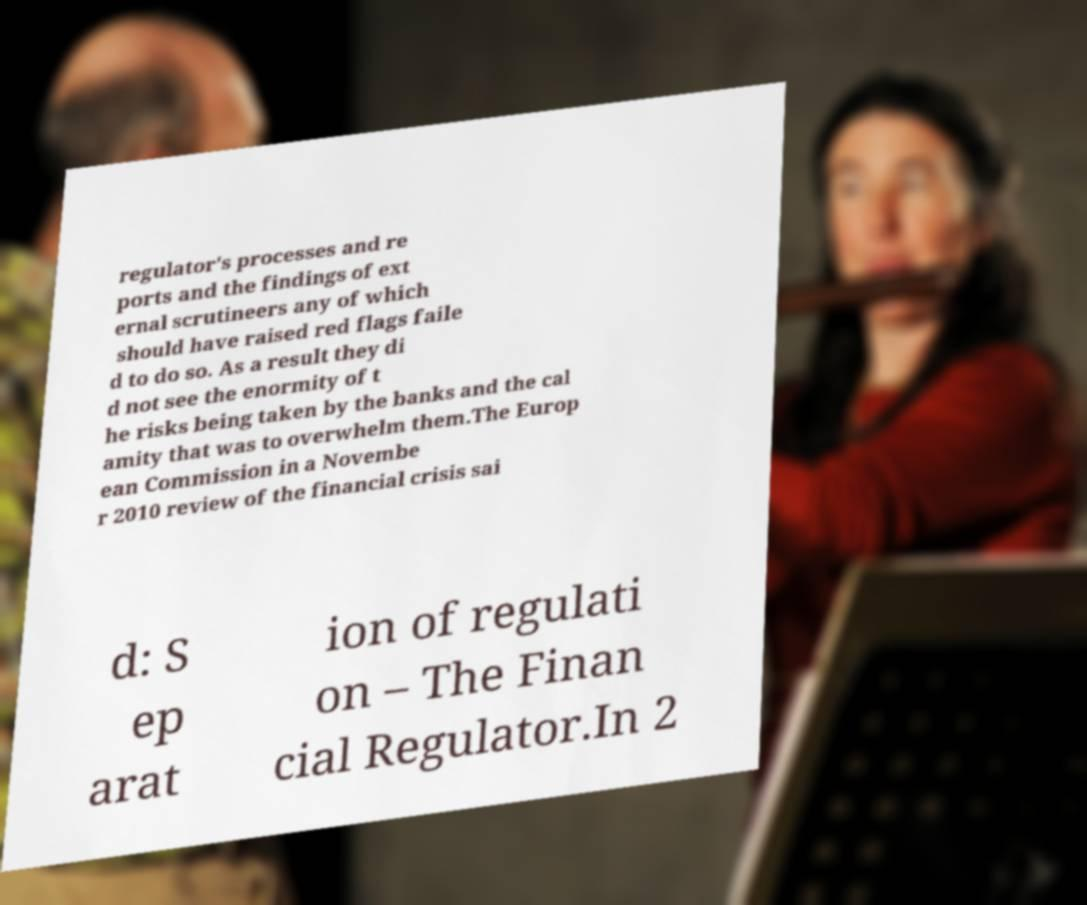Please identify and transcribe the text found in this image. regulator's processes and re ports and the findings of ext ernal scrutineers any of which should have raised red flags faile d to do so. As a result they di d not see the enormity of t he risks being taken by the banks and the cal amity that was to overwhelm them.The Europ ean Commission in a Novembe r 2010 review of the financial crisis sai d: S ep arat ion of regulati on – The Finan cial Regulator.In 2 